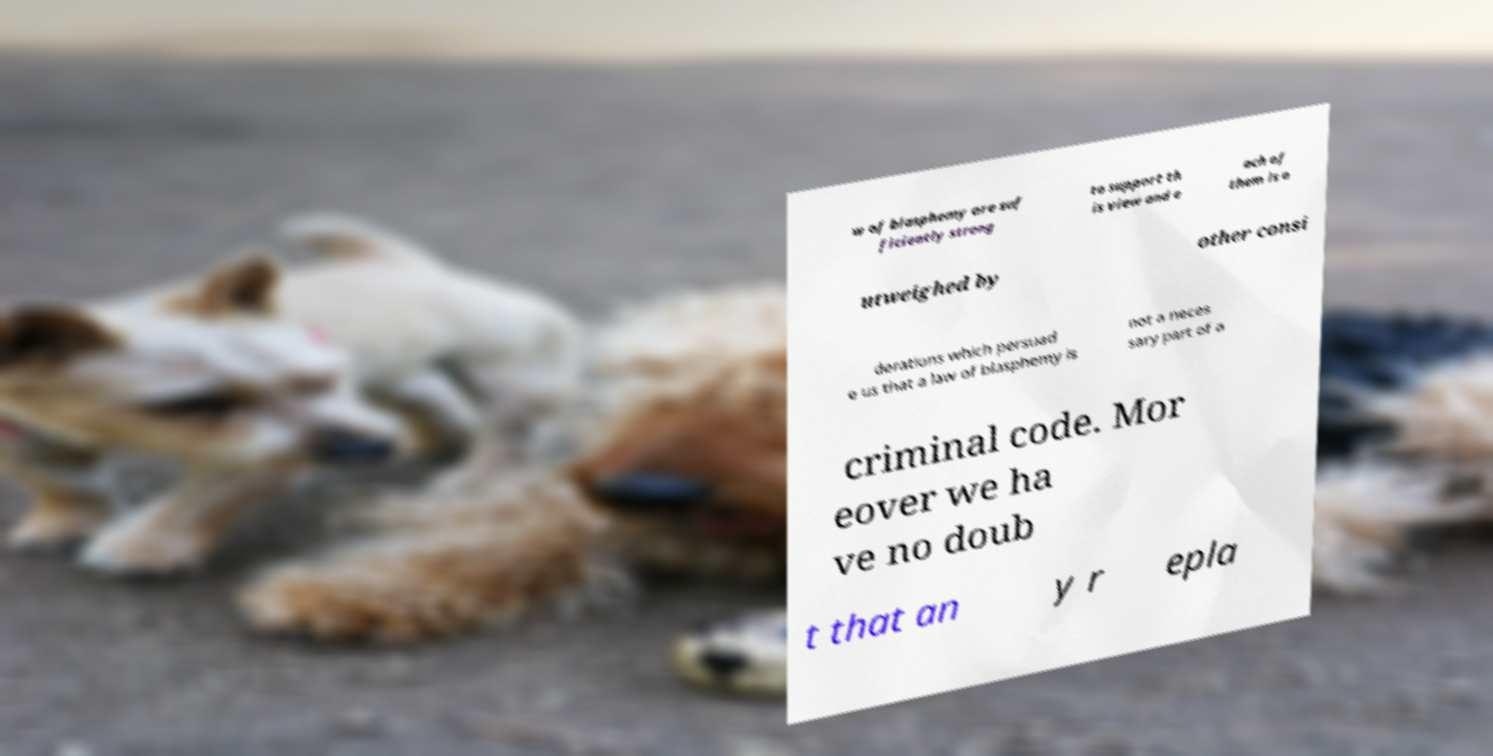Please identify and transcribe the text found in this image. w of blasphemy are suf ficiently strong to support th is view and e ach of them is o utweighed by other consi derations which persuad e us that a law of blasphemy is not a neces sary part of a criminal code. Mor eover we ha ve no doub t that an y r epla 